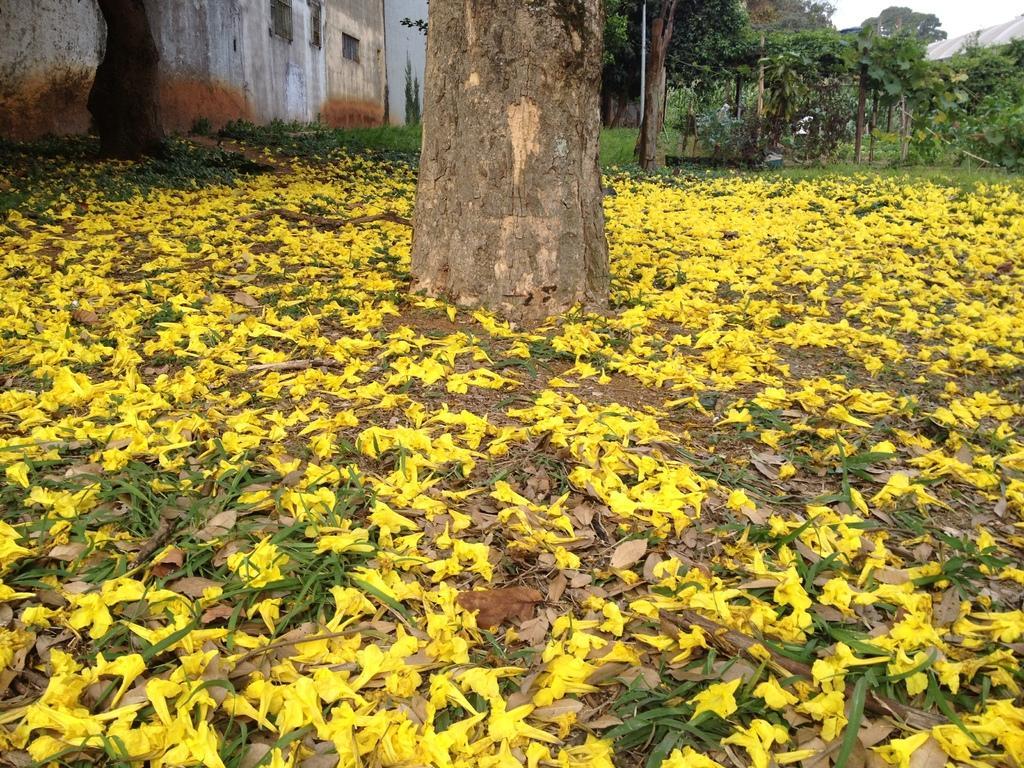Describe this image in one or two sentences. In this image I can see trees,buildings and wall. I can see few yellow color flowers on the ground. 